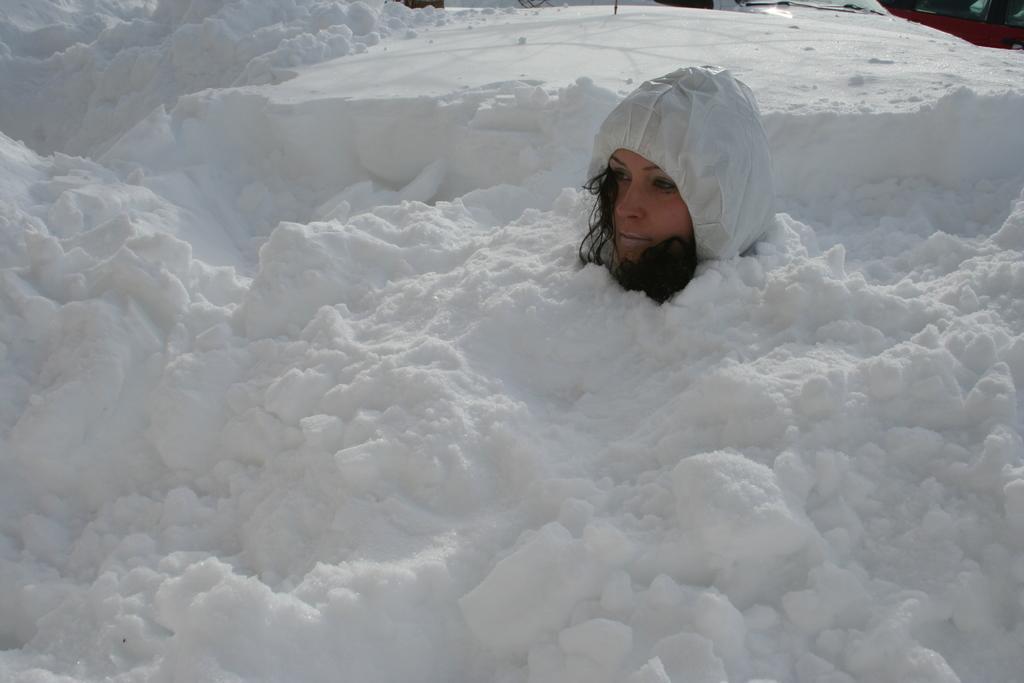Please provide a concise description of this image. In the image we can see there is a woman sitting under the snow and the ground is covered with snow. The woman is wearing hoodie. 